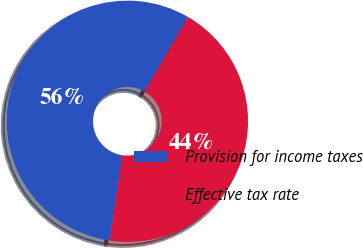<chart> <loc_0><loc_0><loc_500><loc_500><pie_chart><fcel>Provision for income taxes<fcel>Effective tax rate<nl><fcel>56.06%<fcel>43.94%<nl></chart> 